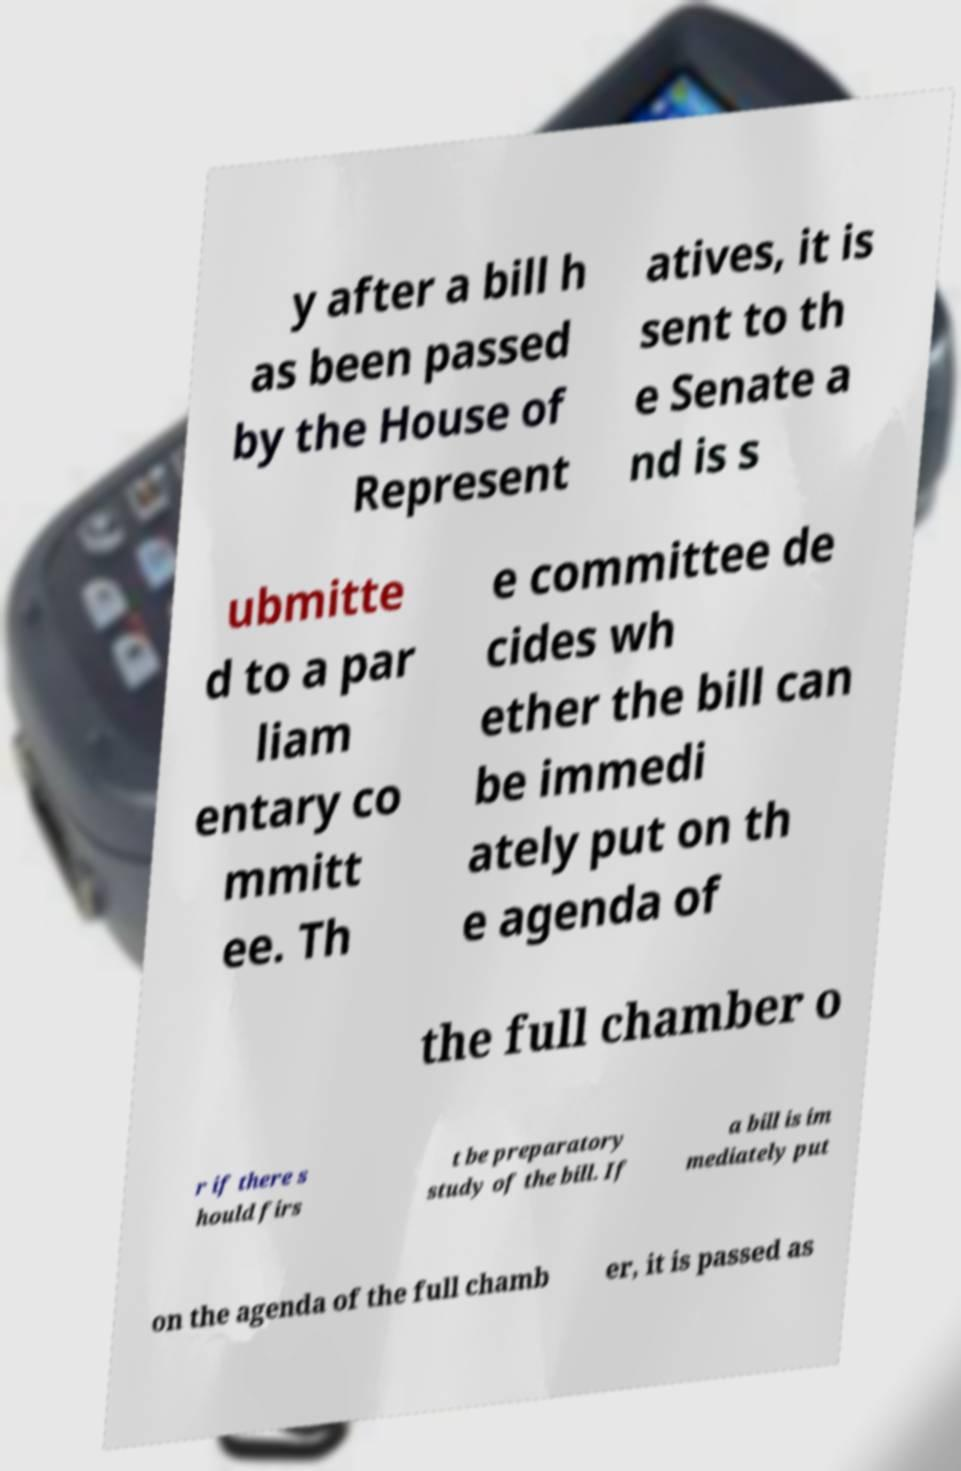I need the written content from this picture converted into text. Can you do that? y after a bill h as been passed by the House of Represent atives, it is sent to th e Senate a nd is s ubmitte d to a par liam entary co mmitt ee. Th e committee de cides wh ether the bill can be immedi ately put on th e agenda of the full chamber o r if there s hould firs t be preparatory study of the bill. If a bill is im mediately put on the agenda of the full chamb er, it is passed as 